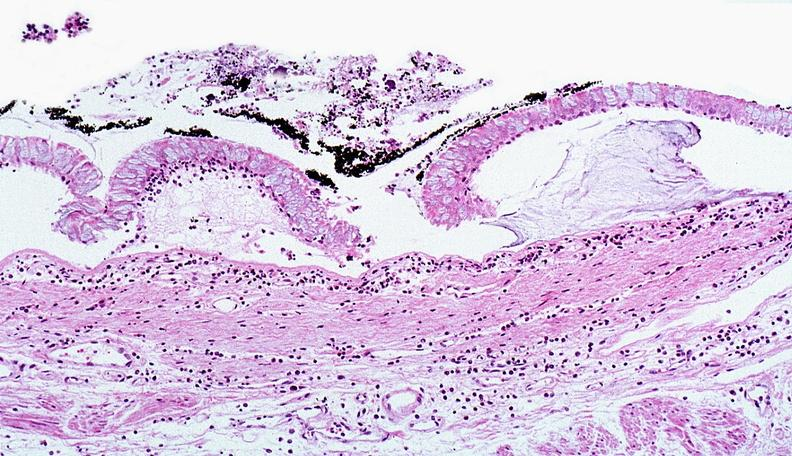does this photo of infant from head to toe show thermal burned skin?
Answer the question using a single word or phrase. No 